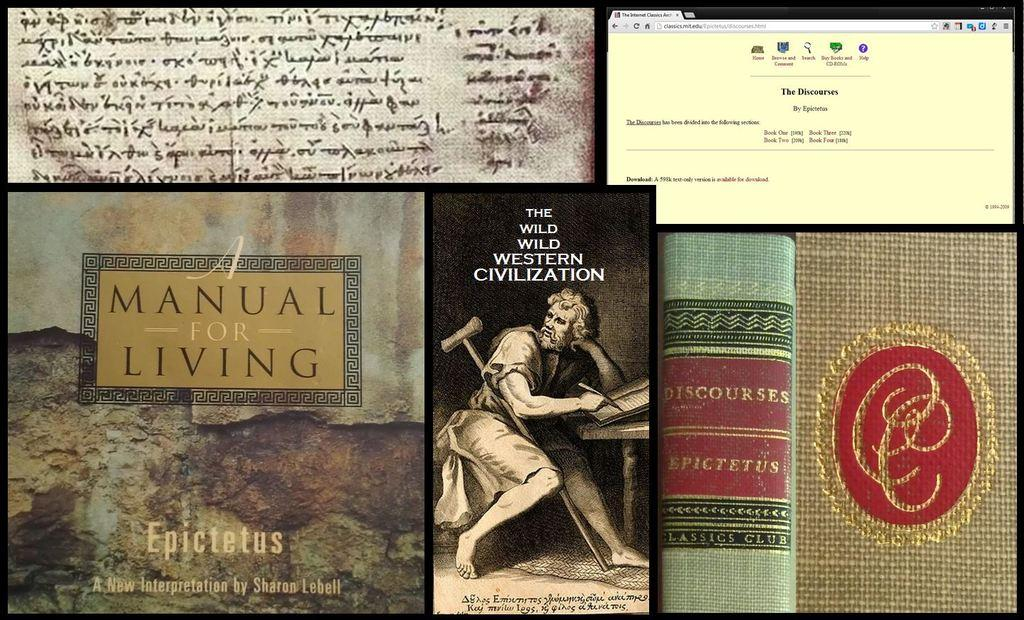<image>
Write a terse but informative summary of the picture. A collage featuring books and book related info contains the titles A Manual for Living, Discourses and The Wild Wild Western Civilization. 